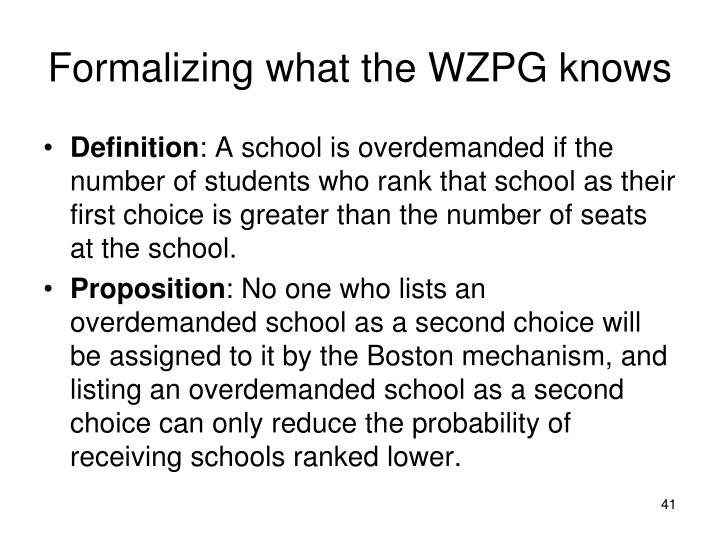What implications does the proposition have on the strategy that students might use when ranking schools? Based on the information depicted in the image regarding the Boston mechanism for school allocation, students should consider strategically ranking schools. The proposition underscores that listing a highly demanded school as a second choice does not increase the likelihood of assignment to that school. In fact, it diminishes the possibility of getting assigned to other preferred schools that are ranked later. Therefore, students should astutely assess the demand levels of their preferred schools and could benefit from placing moderately demanded schools higher on their list. This approach ensures they maximize their chances of acceptance into a good school, while still considering their ultimate preferences. This strategic insight is crucial for navigating the potentially counterintuitive aspects of the choice mechanism effectively. 